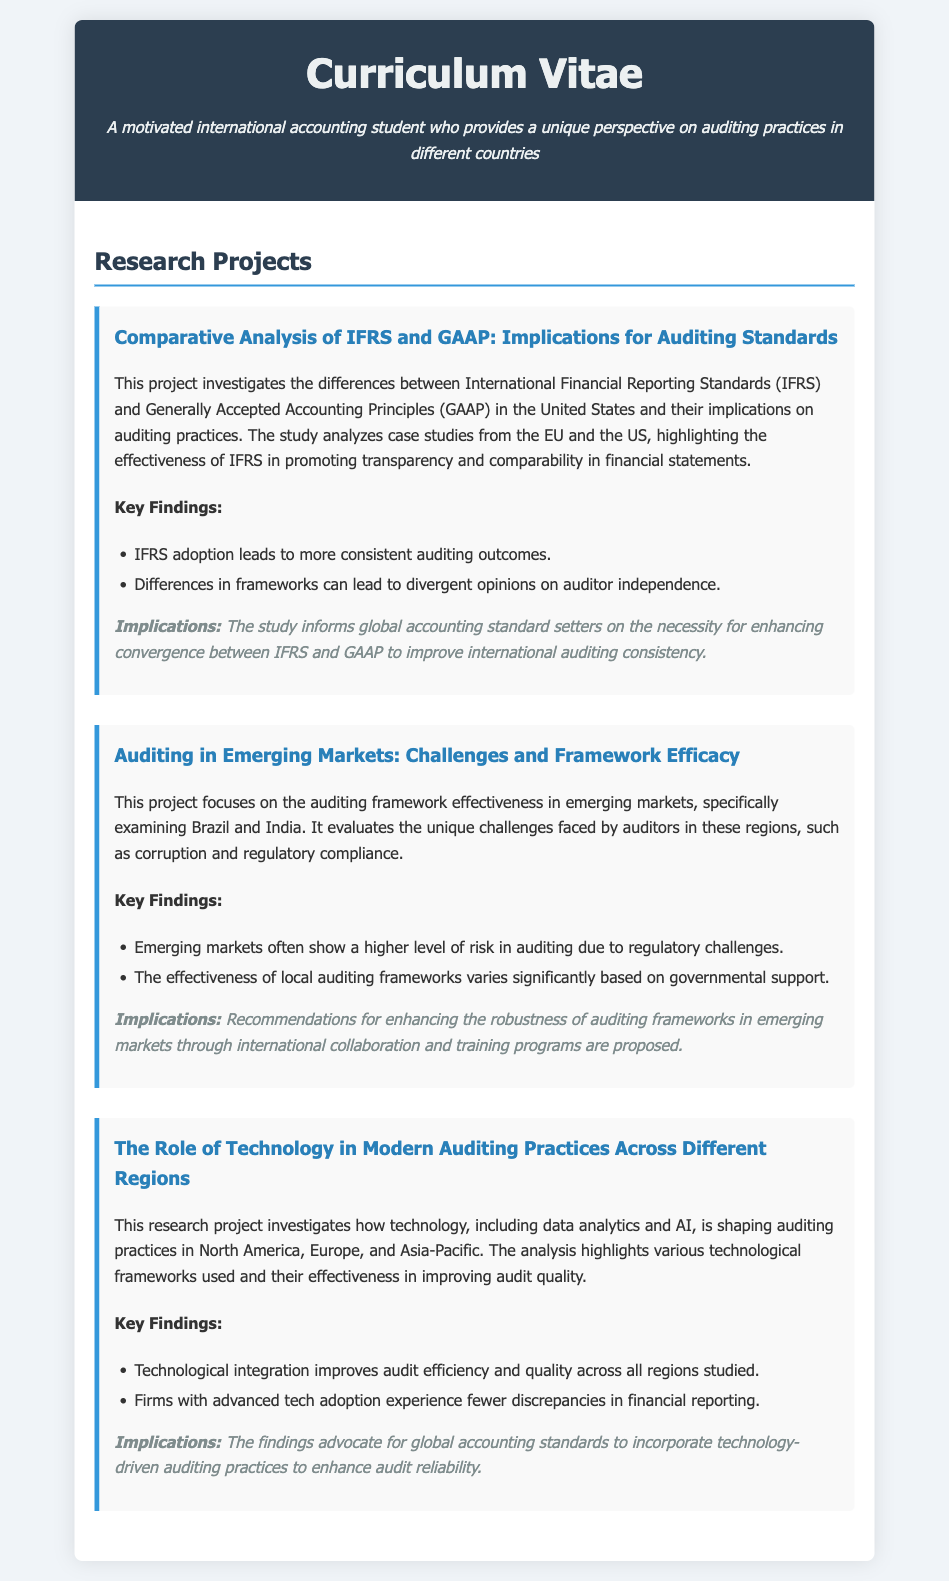What is the title of the first research project? The title is clearly mentioned at the beginning of the first project section, which is "Comparative Analysis of IFRS and GAAP: Implications for Auditing Standards."
Answer: Comparative Analysis of IFRS and GAAP: Implications for Auditing Standards Which countries are analyzed in the second research project? The second project specifically mentions Brazil and India, focusing on their auditing framework effectiveness.
Answer: Brazil and India What is one of the key findings from the project on IFRS and GAAP? One key finding states that IFRS adoption leads to more consistent auditing outcomes, which is listed in the findings section.
Answer: IFRS adoption leads to more consistent auditing outcomes What challenge is associated with auditing in emerging markets? The document highlights corruption and regulatory compliance as unique challenges faced by auditors in emerging markets.
Answer: Corruption and regulatory compliance What role does technology play according to the third research project? The project discusses how technology is shaping auditing practices, particularly highlighting its impact on efficiency and quality.
Answer: Shaping auditing practices What is one implication from the technology in auditing practices project? The implications suggest incorporating technology-driven auditing practices to enhance audit reliability as a key recommendation.
Answer: Enhance audit reliability 